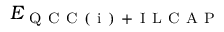<formula> <loc_0><loc_0><loc_500><loc_500>E _ { Q C C ( i ) + I L C A P }</formula> 